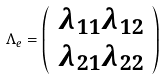<formula> <loc_0><loc_0><loc_500><loc_500>\Lambda _ { e } = \left ( \begin{array} { l l l l } \lambda _ { 1 1 } \lambda _ { 1 2 } \\ \lambda _ { 2 1 } \lambda _ { 2 2 } \end{array} \right )</formula> 